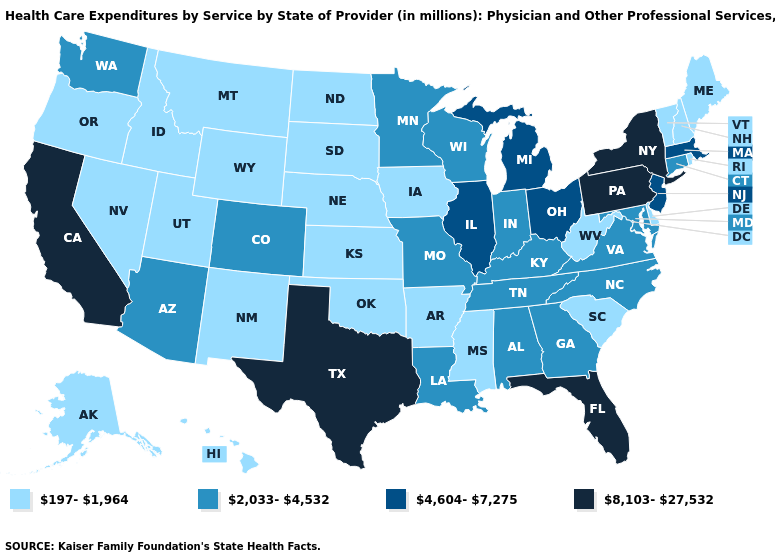What is the value of Oregon?
Answer briefly. 197-1,964. Does the first symbol in the legend represent the smallest category?
Answer briefly. Yes. Name the states that have a value in the range 8,103-27,532?
Give a very brief answer. California, Florida, New York, Pennsylvania, Texas. Which states have the lowest value in the MidWest?
Be succinct. Iowa, Kansas, Nebraska, North Dakota, South Dakota. What is the value of Kansas?
Answer briefly. 197-1,964. Which states have the lowest value in the USA?
Short answer required. Alaska, Arkansas, Delaware, Hawaii, Idaho, Iowa, Kansas, Maine, Mississippi, Montana, Nebraska, Nevada, New Hampshire, New Mexico, North Dakota, Oklahoma, Oregon, Rhode Island, South Carolina, South Dakota, Utah, Vermont, West Virginia, Wyoming. Among the states that border Oklahoma , which have the highest value?
Short answer required. Texas. Name the states that have a value in the range 2,033-4,532?
Give a very brief answer. Alabama, Arizona, Colorado, Connecticut, Georgia, Indiana, Kentucky, Louisiana, Maryland, Minnesota, Missouri, North Carolina, Tennessee, Virginia, Washington, Wisconsin. Name the states that have a value in the range 2,033-4,532?
Keep it brief. Alabama, Arizona, Colorado, Connecticut, Georgia, Indiana, Kentucky, Louisiana, Maryland, Minnesota, Missouri, North Carolina, Tennessee, Virginia, Washington, Wisconsin. What is the highest value in the Northeast ?
Give a very brief answer. 8,103-27,532. Is the legend a continuous bar?
Answer briefly. No. What is the value of Mississippi?
Write a very short answer. 197-1,964. Which states have the lowest value in the West?
Quick response, please. Alaska, Hawaii, Idaho, Montana, Nevada, New Mexico, Oregon, Utah, Wyoming. What is the value of New Hampshire?
Keep it brief. 197-1,964. Which states have the highest value in the USA?
Concise answer only. California, Florida, New York, Pennsylvania, Texas. 